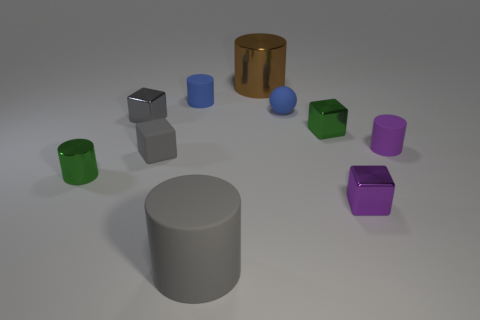How many objects are in this image, and can you group them by color? There are ten objects in this image. Grouping them by color: we have two green objects, two blue, one gray, one purple, one brown, and three identical cylinders with no color differences. 